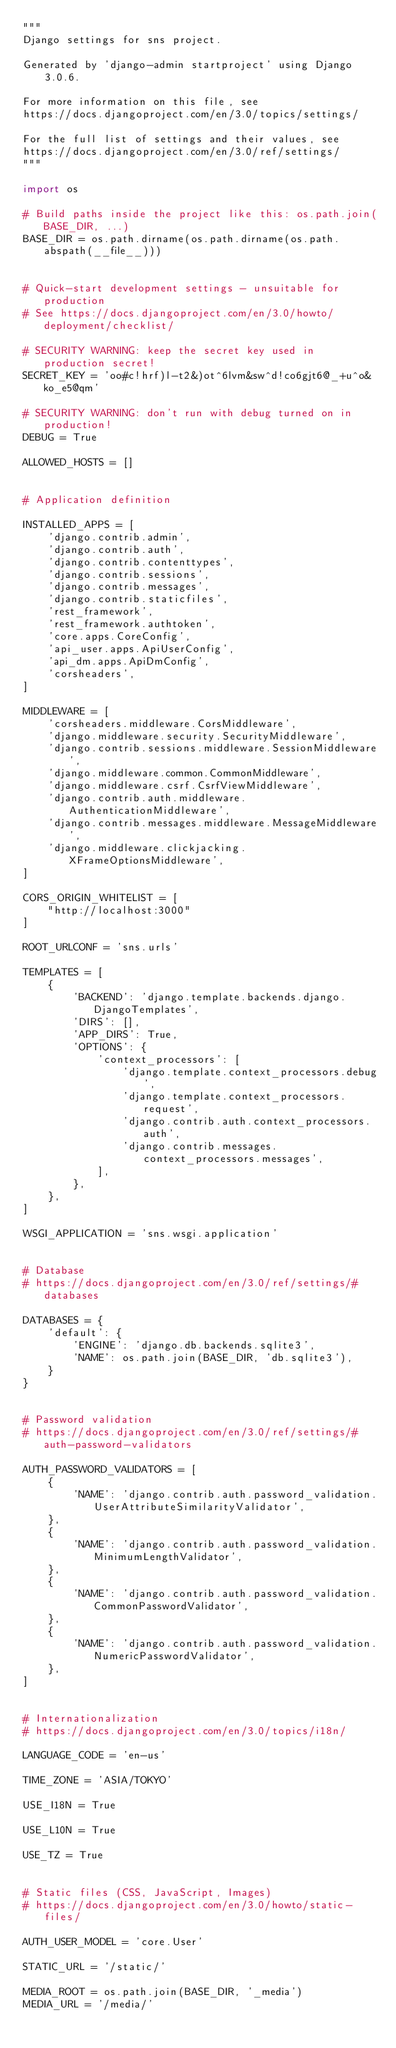<code> <loc_0><loc_0><loc_500><loc_500><_Python_>"""
Django settings for sns project.

Generated by 'django-admin startproject' using Django 3.0.6.

For more information on this file, see
https://docs.djangoproject.com/en/3.0/topics/settings/

For the full list of settings and their values, see
https://docs.djangoproject.com/en/3.0/ref/settings/
"""

import os

# Build paths inside the project like this: os.path.join(BASE_DIR, ...)
BASE_DIR = os.path.dirname(os.path.dirname(os.path.abspath(__file__)))


# Quick-start development settings - unsuitable for production
# See https://docs.djangoproject.com/en/3.0/howto/deployment/checklist/

# SECURITY WARNING: keep the secret key used in production secret!
SECRET_KEY = 'oo#c!hrf)l-t2&)ot^6lvm&sw^d!co6gjt6@_+u^o&ko_e5@qm'

# SECURITY WARNING: don't run with debug turned on in production!
DEBUG = True

ALLOWED_HOSTS = []


# Application definition

INSTALLED_APPS = [
    'django.contrib.admin',
    'django.contrib.auth',
    'django.contrib.contenttypes',
    'django.contrib.sessions',
    'django.contrib.messages',
    'django.contrib.staticfiles',
    'rest_framework',
    'rest_framework.authtoken',
    'core.apps.CoreConfig',
    'api_user.apps.ApiUserConfig',
    'api_dm.apps.ApiDmConfig',
    'corsheaders',
]

MIDDLEWARE = [
    'corsheaders.middleware.CorsMiddleware',
    'django.middleware.security.SecurityMiddleware',
    'django.contrib.sessions.middleware.SessionMiddleware',
    'django.middleware.common.CommonMiddleware',
    'django.middleware.csrf.CsrfViewMiddleware',
    'django.contrib.auth.middleware.AuthenticationMiddleware',
    'django.contrib.messages.middleware.MessageMiddleware',
    'django.middleware.clickjacking.XFrameOptionsMiddleware',
]

CORS_ORIGIN_WHITELIST = [
    "http://localhost:3000"
]

ROOT_URLCONF = 'sns.urls'

TEMPLATES = [
    {
        'BACKEND': 'django.template.backends.django.DjangoTemplates',
        'DIRS': [],
        'APP_DIRS': True,
        'OPTIONS': {
            'context_processors': [
                'django.template.context_processors.debug',
                'django.template.context_processors.request',
                'django.contrib.auth.context_processors.auth',
                'django.contrib.messages.context_processors.messages',
            ],
        },
    },
]

WSGI_APPLICATION = 'sns.wsgi.application'


# Database
# https://docs.djangoproject.com/en/3.0/ref/settings/#databases

DATABASES = {
    'default': {
        'ENGINE': 'django.db.backends.sqlite3',
        'NAME': os.path.join(BASE_DIR, 'db.sqlite3'),
    }
}


# Password validation
# https://docs.djangoproject.com/en/3.0/ref/settings/#auth-password-validators

AUTH_PASSWORD_VALIDATORS = [
    {
        'NAME': 'django.contrib.auth.password_validation.UserAttributeSimilarityValidator',
    },
    {
        'NAME': 'django.contrib.auth.password_validation.MinimumLengthValidator',
    },
    {
        'NAME': 'django.contrib.auth.password_validation.CommonPasswordValidator',
    },
    {
        'NAME': 'django.contrib.auth.password_validation.NumericPasswordValidator',
    },
]


# Internationalization
# https://docs.djangoproject.com/en/3.0/topics/i18n/

LANGUAGE_CODE = 'en-us'

TIME_ZONE = 'ASIA/TOKYO'

USE_I18N = True

USE_L10N = True

USE_TZ = True


# Static files (CSS, JavaScript, Images)
# https://docs.djangoproject.com/en/3.0/howto/static-files/

AUTH_USER_MODEL = 'core.User'

STATIC_URL = '/static/'

MEDIA_ROOT = os.path.join(BASE_DIR, '_media')
MEDIA_URL = '/media/'</code> 